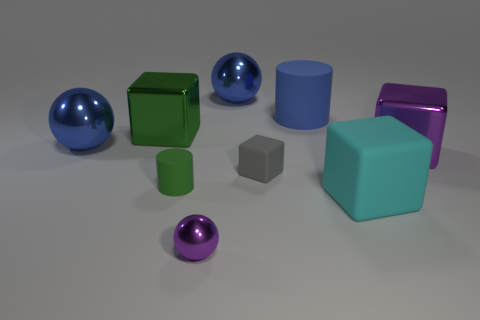Subtract all blue shiny balls. How many balls are left? 1 Add 1 large shiny spheres. How many objects exist? 10 Subtract all purple balls. How many balls are left? 2 Subtract all cylinders. How many objects are left? 7 Subtract 1 purple balls. How many objects are left? 8 Subtract 1 cylinders. How many cylinders are left? 1 Subtract all purple cylinders. Subtract all red balls. How many cylinders are left? 2 Subtract all red balls. How many brown cylinders are left? 0 Subtract all large metallic cubes. Subtract all green blocks. How many objects are left? 6 Add 6 big purple metallic blocks. How many big purple metallic blocks are left? 7 